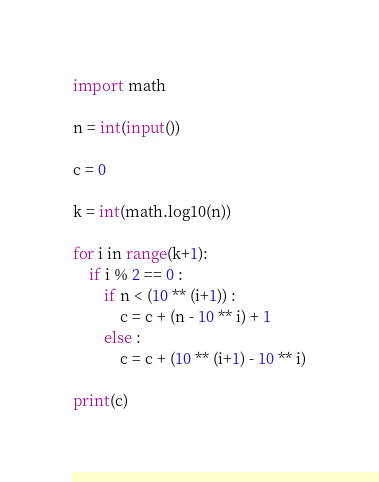<code> <loc_0><loc_0><loc_500><loc_500><_Python_>import math

n = int(input())

c = 0

k = int(math.log10(n)) 

for i in range(k+1):
    if i % 2 == 0 :
        if n < (10 ** (i+1)) :
            c = c + (n - 10 ** i) + 1
        else :
            c = c + (10 ** (i+1) - 10 ** i)

print(c)</code> 